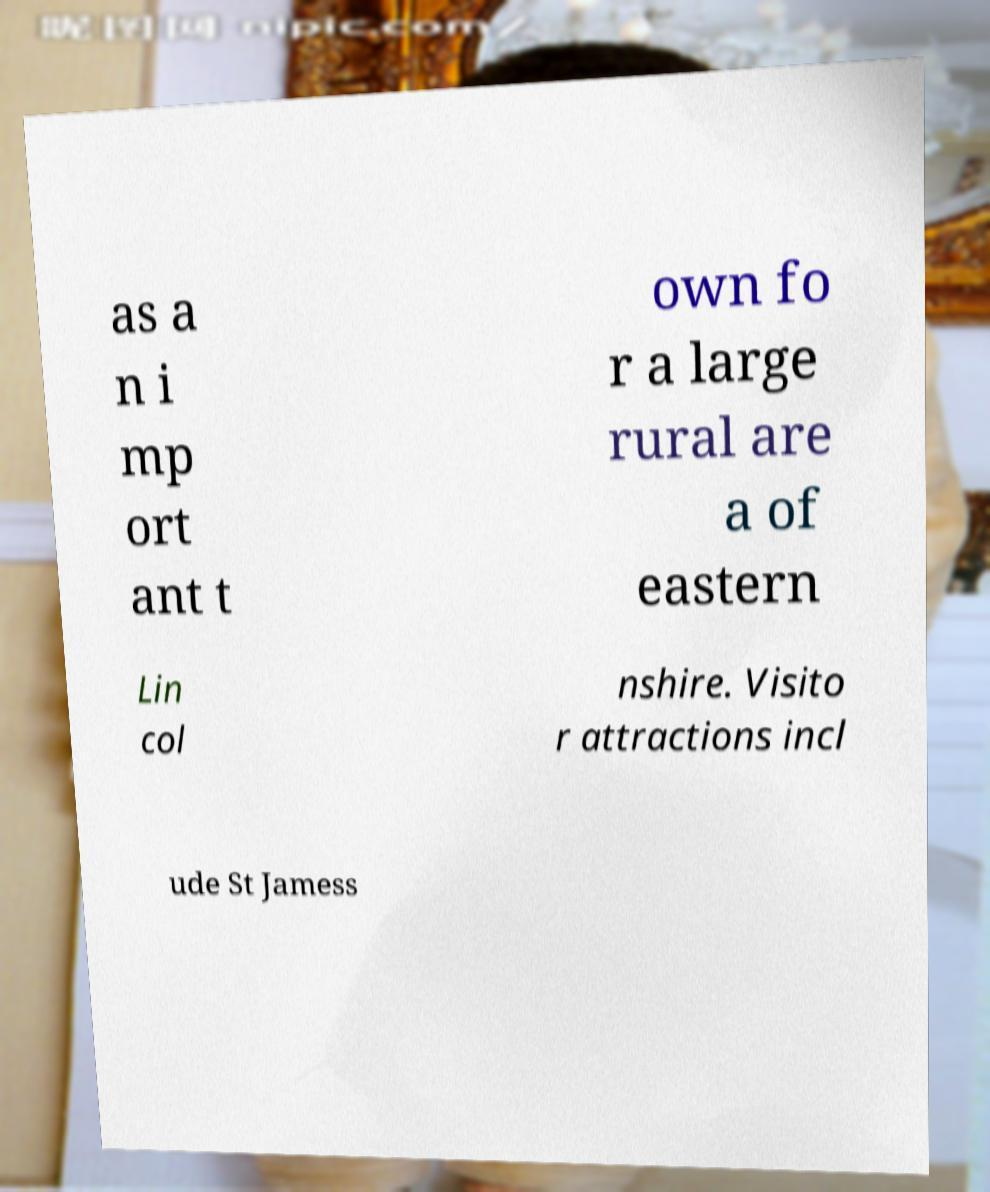What messages or text are displayed in this image? I need them in a readable, typed format. as a n i mp ort ant t own fo r a large rural are a of eastern Lin col nshire. Visito r attractions incl ude St Jamess 